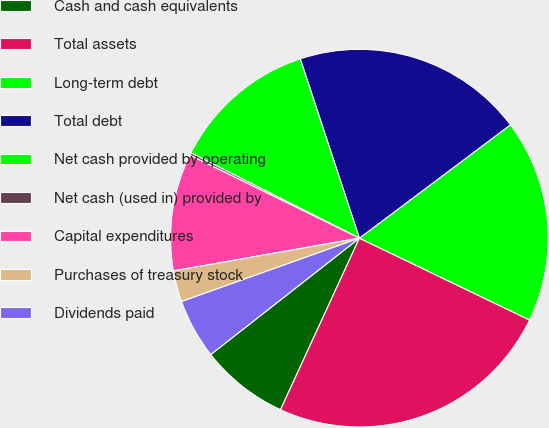Convert chart to OTSL. <chart><loc_0><loc_0><loc_500><loc_500><pie_chart><fcel>Cash and cash equivalents<fcel>Total assets<fcel>Long-term debt<fcel>Total debt<fcel>Net cash provided by operating<fcel>Net cash (used in) provided by<fcel>Capital expenditures<fcel>Purchases of treasury stock<fcel>Dividends paid<nl><fcel>7.57%<fcel>24.73%<fcel>17.38%<fcel>19.83%<fcel>12.47%<fcel>0.22%<fcel>10.02%<fcel>2.67%<fcel>5.12%<nl></chart> 